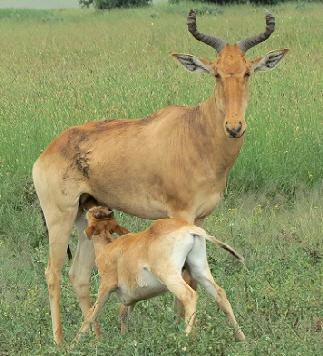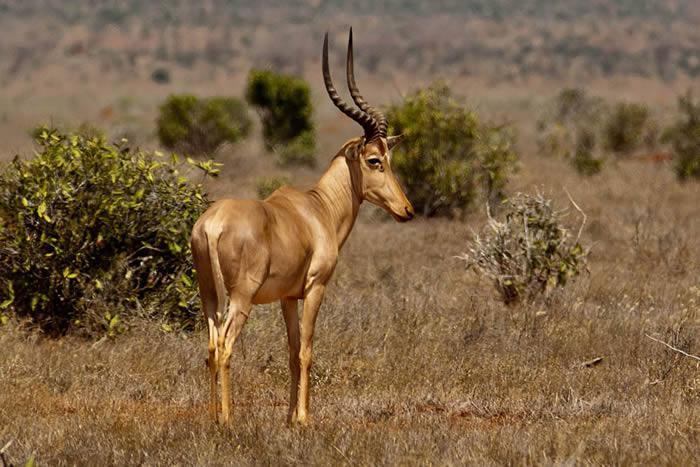The first image is the image on the left, the second image is the image on the right. Given the left and right images, does the statement "The two images contain a total of three animals." hold true? Answer yes or no. Yes. The first image is the image on the left, the second image is the image on the right. For the images shown, is this caption "An image shows just one horned animal, standing with its head in profile." true? Answer yes or no. Yes. 